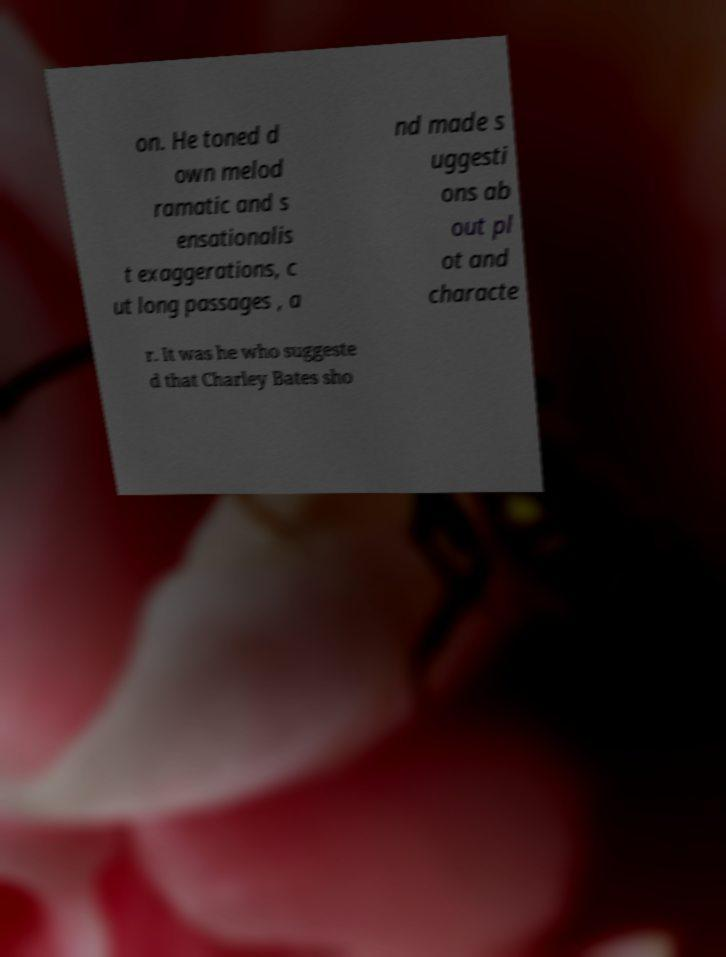For documentation purposes, I need the text within this image transcribed. Could you provide that? on. He toned d own melod ramatic and s ensationalis t exaggerations, c ut long passages , a nd made s uggesti ons ab out pl ot and characte r. It was he who suggeste d that Charley Bates sho 